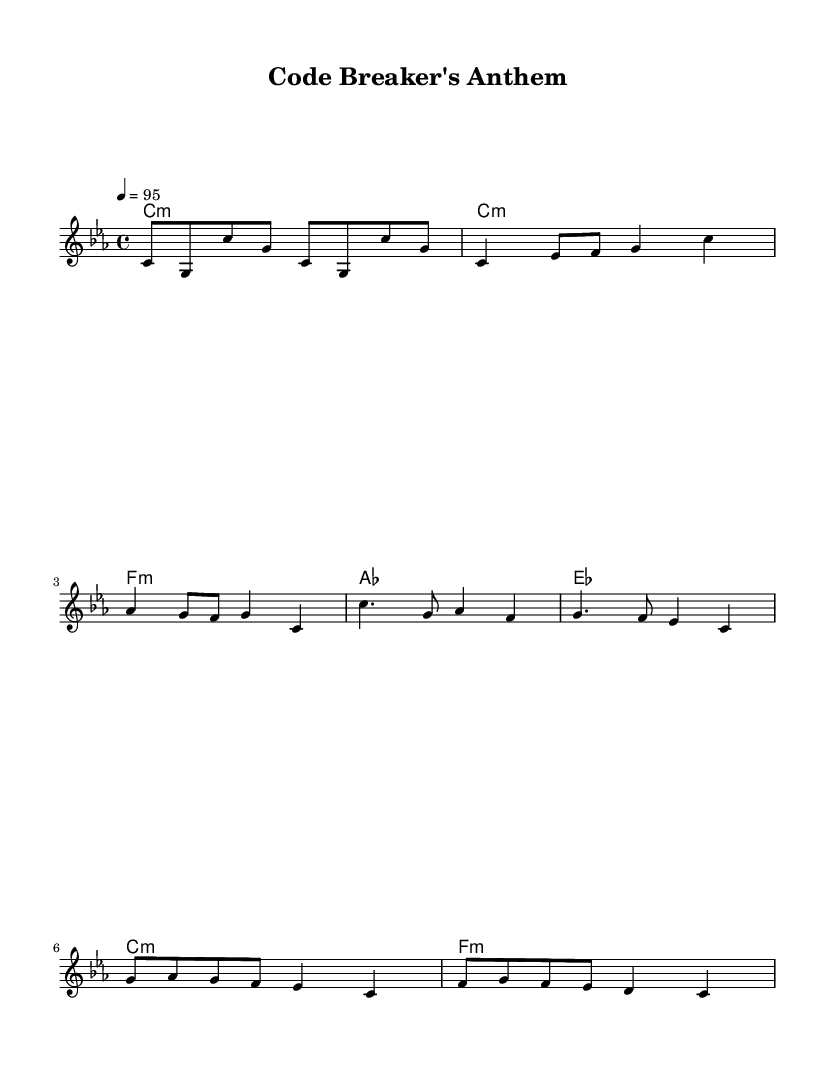what is the key signature of this music? The key signature is C minor, which has three flats (B♭, E♭, A♭). This can be identified at the beginning of the piece, visible on the staff.
Answer: C minor what is the time signature of this music? The time signature is 4/4, which means there are four beats in a measure and the quarter note gets one beat. This is indicated in the top left of the sheet music.
Answer: 4/4 what is the tempo marking of this music? The tempo marking is quarter note = 95, indicating the speed at which the music should be played. This marking is located at the beginning of the score.
Answer: 95 how many measures are in the intro section? The intro consists of two measures based on the provided melody line; this can be verified by counting the measures where the melody’s notes are laid out.
Answer: 2 which chord is played during the chorus? The chords during the chorus include A♭ major and E♭ major. This can be found by looking at the chord symbols placed above the melody line during the chorus section.
Answer: A♭ major, E♭ major what is the last note of the melody? The last note of the melody is C. This can be determined by looking closely at the final bar of the melody.
Answer: C how does the rhythm in the bridge compare to that in the verse? The rhythm in the bridge features a mix of eighth notes and a quarter note, while the verse is more straightforward with mostly quarter notes. Analyzing the rhythmic note values in both sections reveals this difference.
Answer: More varied 